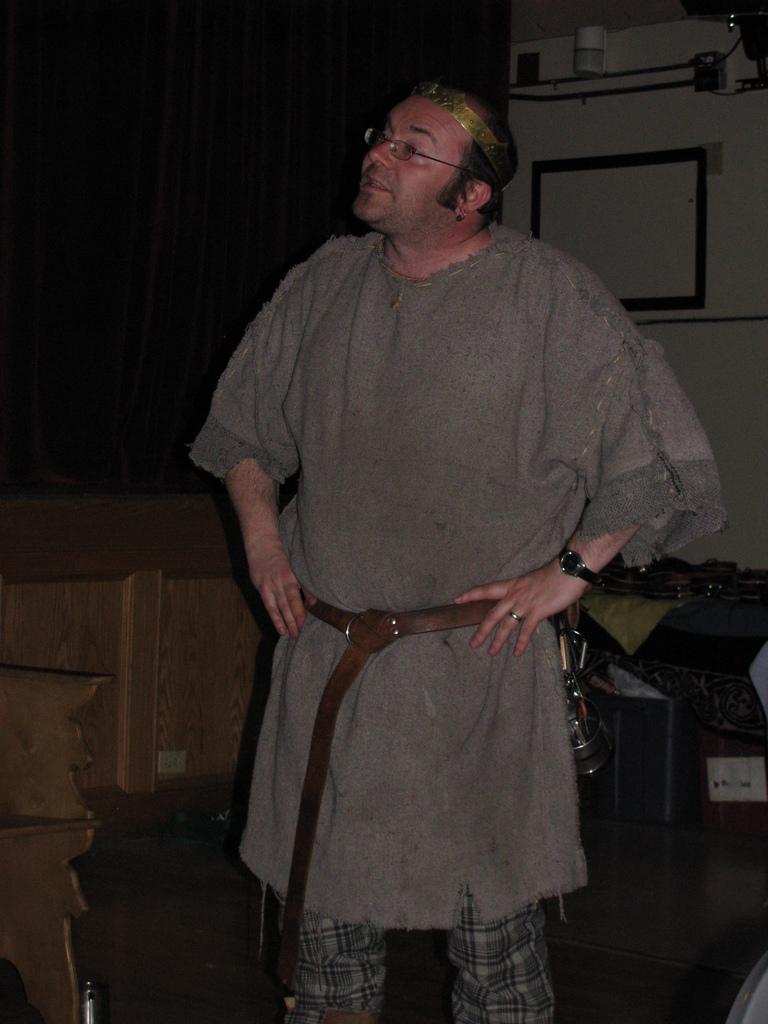Could you give a brief overview of what you see in this image? In this image we can see a man with glasses standing. In the background we can see the curtain and also a frame attached to the wall. At the bottom we can see the floor. There is also a wooden object on the left. On the right there is a cloth. 